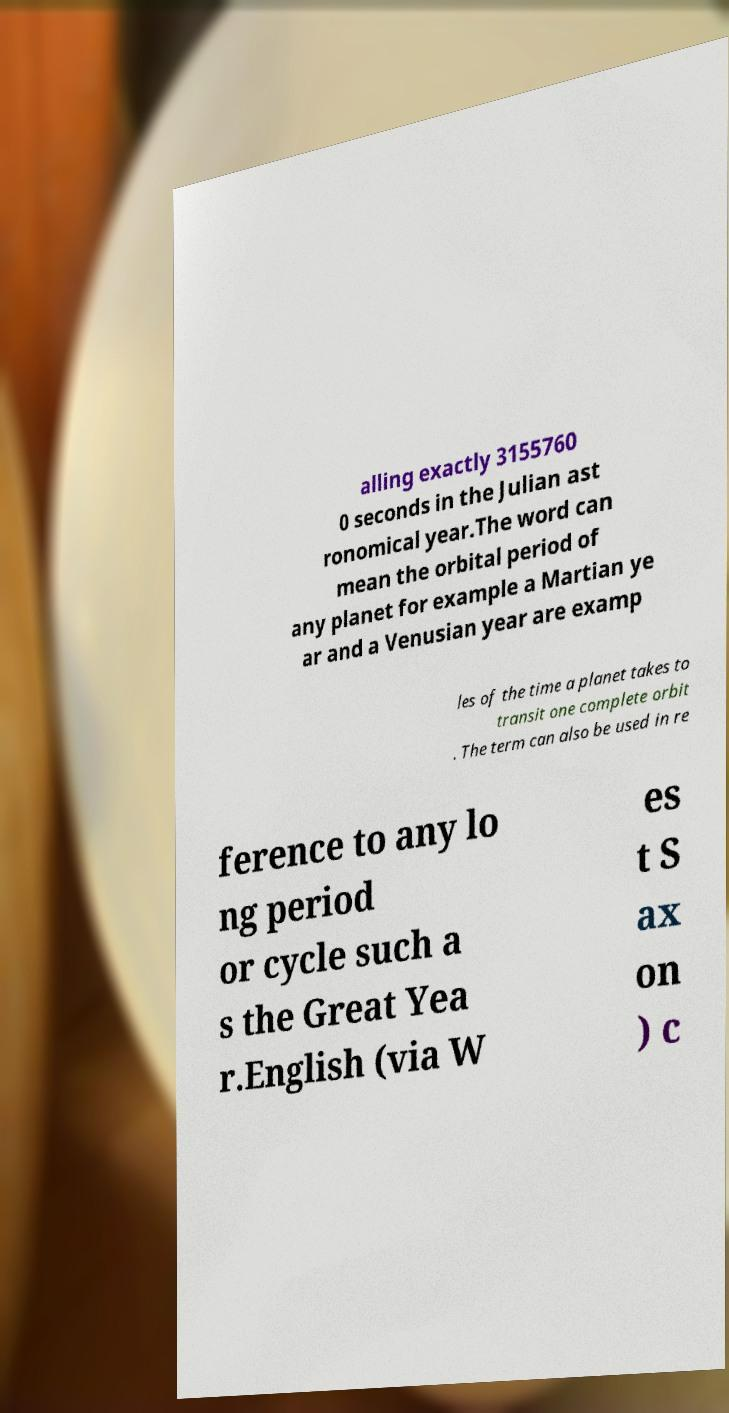Please read and relay the text visible in this image. What does it say? alling exactly 3155760 0 seconds in the Julian ast ronomical year.The word can mean the orbital period of any planet for example a Martian ye ar and a Venusian year are examp les of the time a planet takes to transit one complete orbit . The term can also be used in re ference to any lo ng period or cycle such a s the Great Yea r.English (via W es t S ax on ) c 